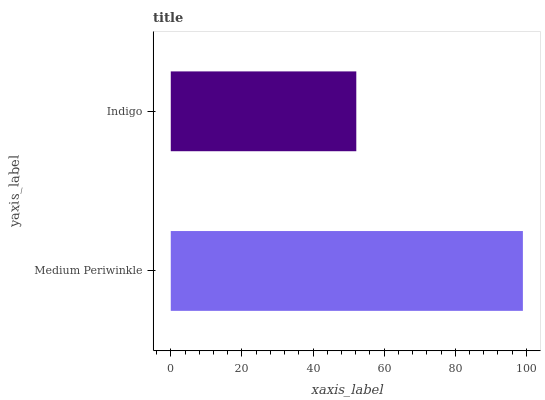Is Indigo the minimum?
Answer yes or no. Yes. Is Medium Periwinkle the maximum?
Answer yes or no. Yes. Is Indigo the maximum?
Answer yes or no. No. Is Medium Periwinkle greater than Indigo?
Answer yes or no. Yes. Is Indigo less than Medium Periwinkle?
Answer yes or no. Yes. Is Indigo greater than Medium Periwinkle?
Answer yes or no. No. Is Medium Periwinkle less than Indigo?
Answer yes or no. No. Is Medium Periwinkle the high median?
Answer yes or no. Yes. Is Indigo the low median?
Answer yes or no. Yes. Is Indigo the high median?
Answer yes or no. No. Is Medium Periwinkle the low median?
Answer yes or no. No. 